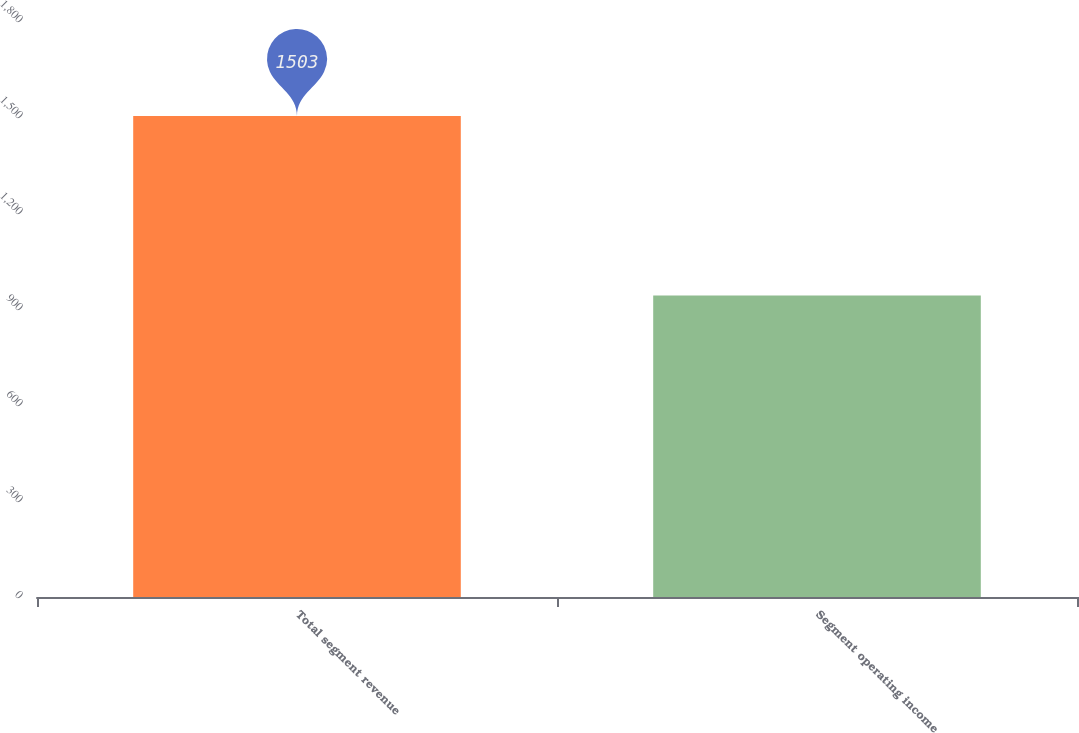<chart> <loc_0><loc_0><loc_500><loc_500><bar_chart><fcel>Total segment revenue<fcel>Segment operating income<nl><fcel>1503<fcel>942<nl></chart> 